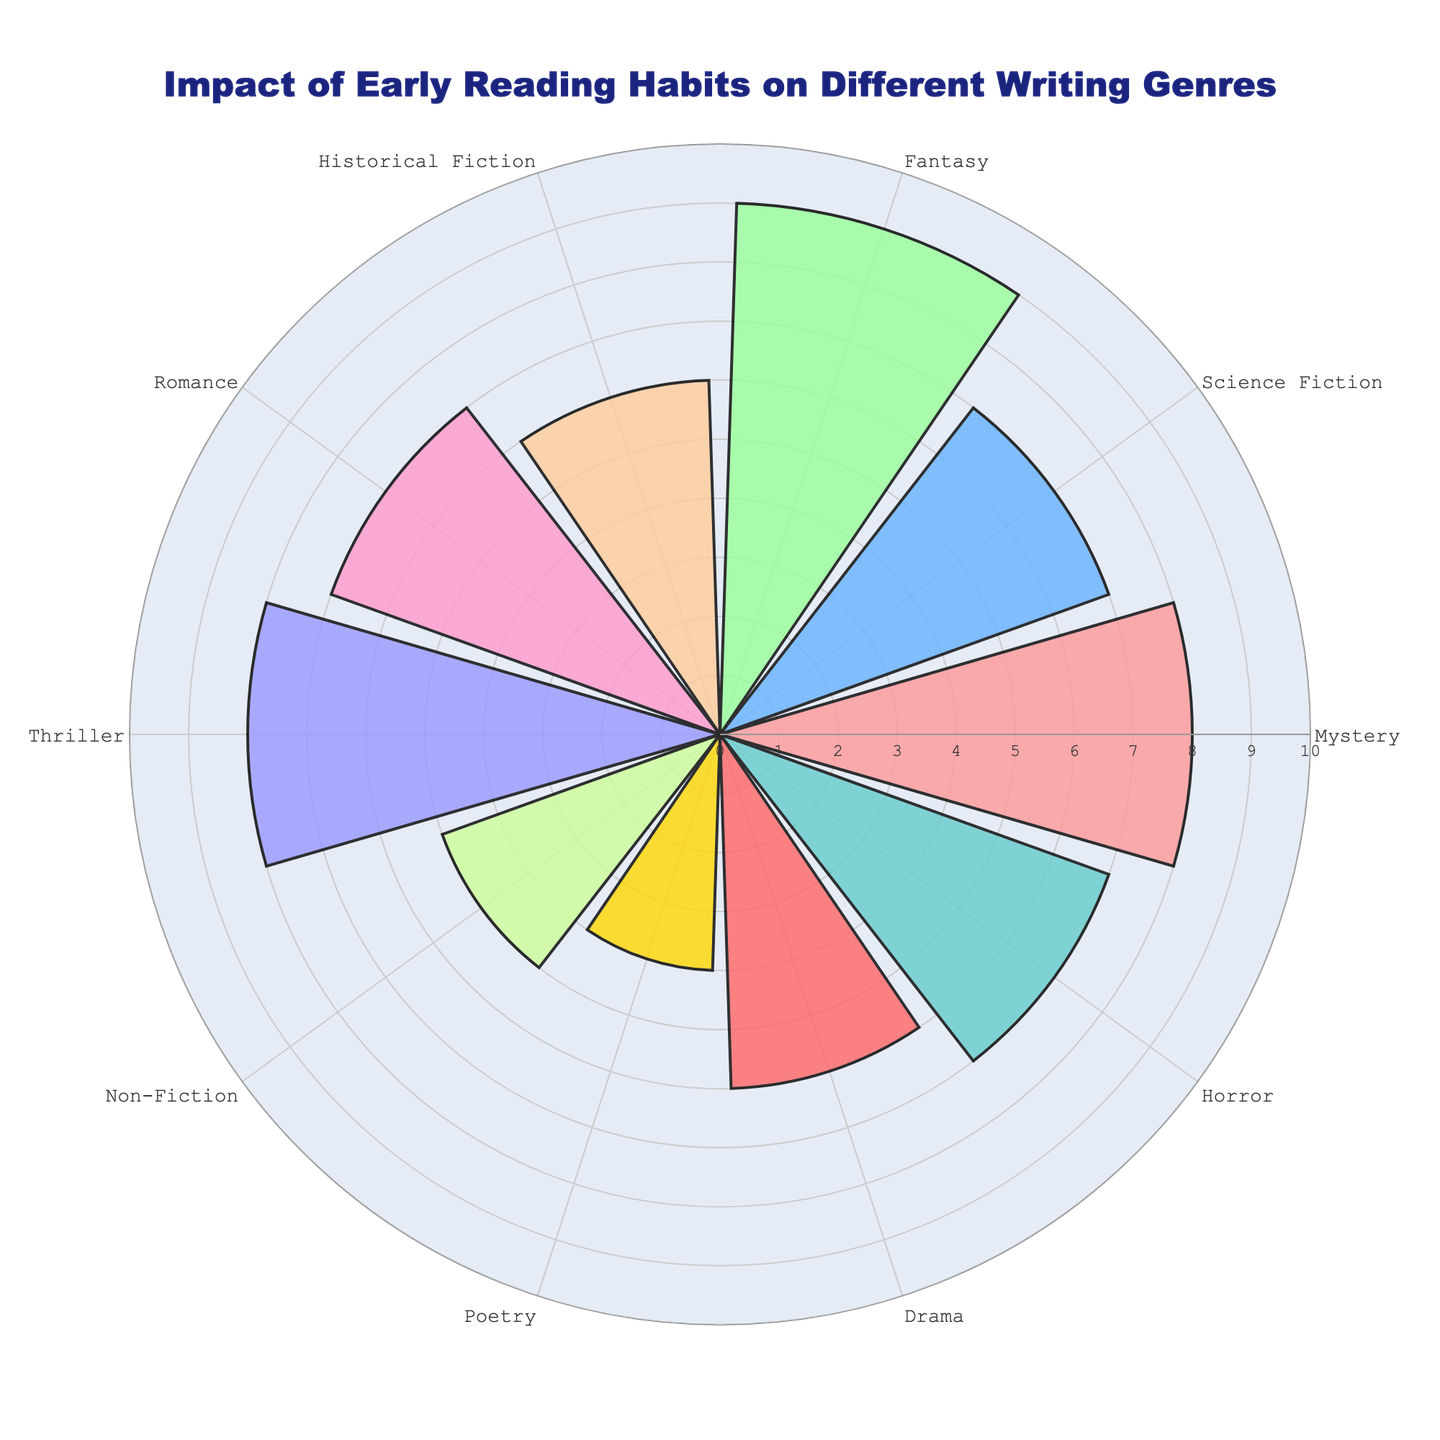What is the title of the figure? The title is positioned at the top-center of the image. This gives a hint about the overall theme or subject of the chart.
Answer: Impact of Early Reading Habits on Different Writing Genres How many genres are represented in the chart? Count the number of distinct segments or bars in the polar area chart. Each bar represents a different genre.
Answer: 10 Which genre shows the highest impact of early reading habits? Look for the segment with the highest radial value (longest bar).
Answer: Fantasy Which genre shows the lowest impact? Identify the segment with the shortest bar in the chart.
Answer: Poetry What is the range of the radial axis? Check the radial axis for the minimum and maximum values to determine its range.
Answer: 0 to 10 What is the average impact of early reading habits on all genres? Sum all radial values for each genre and divide by the number of genres. Calculation: (8+7+9+6+7+8+5+4+6+7) / 10
Answer: 6.7 Which genres have an impact greater than 7? Identify all segments with radial values greater than 7.
Answer: Mystery, Fantasy, Thriller How does the impact on Historical Fiction compare to Drama? Check the radial values for both genres and compare them. Historical Fiction: 6; Drama: 6
Answer: Equal Is the impact on Non-Fiction higher or lower than Romance? Compare the lengths of the bars for Non-Fiction (5) and Romance (7).
Answer: Lower What is the sum of the impact values for Mystery and Horror? Add the radial values of Mystery (8) and Horror (7). Calculation: 8 + 7
Answer: 15 